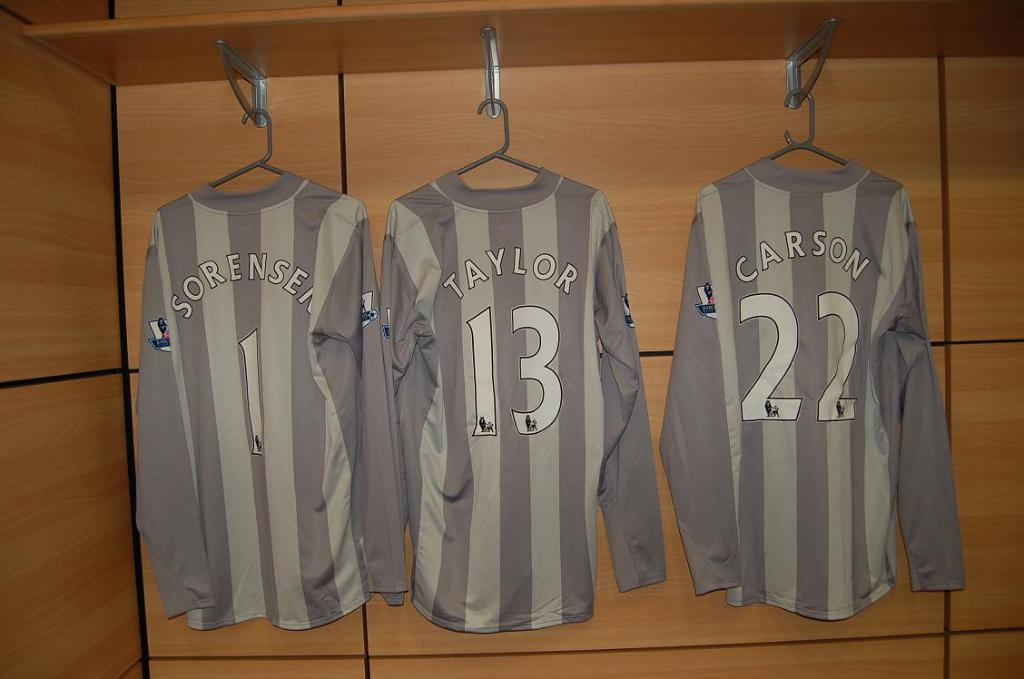Provide a one-sentence caption for the provided image. Three sports uniforms hung on hangers, with the number and last names; Taylor, Carson and Sorensen. 